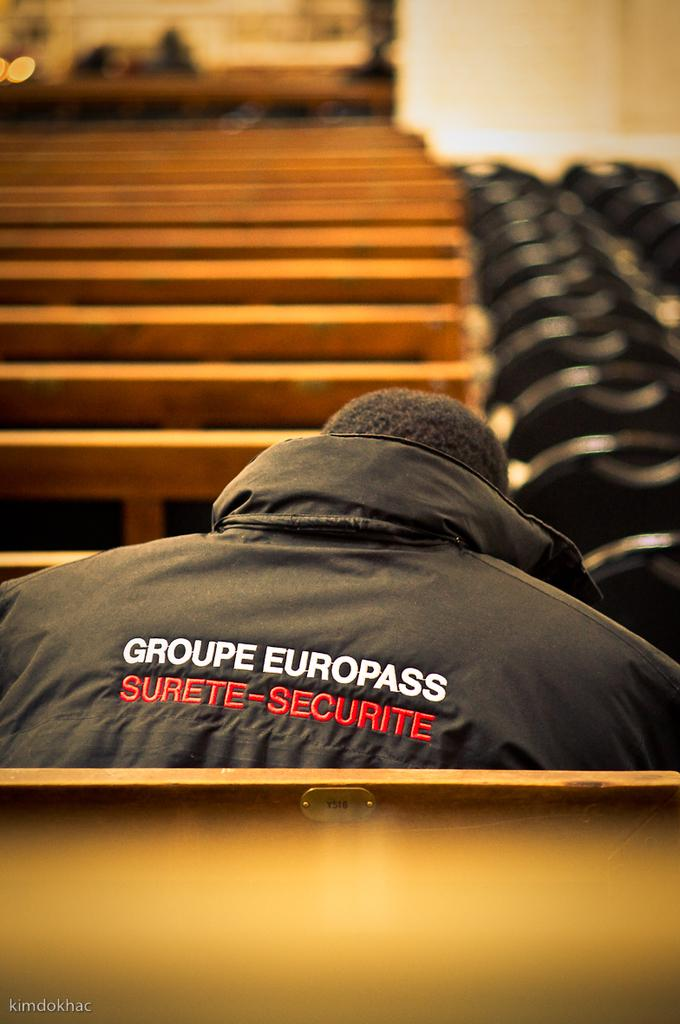What is the main subject in the foreground of the image? There is a person in the foreground of the image. How is the background of the image depicted? The background of the image is blurred. What type of objects can be seen in the background of the image? There are benches and other objects in the background of the image. Can you hear the noise made by the girls jumping in the image? There are no girls or jumping depicted in the image, so there is no noise to be heard. 